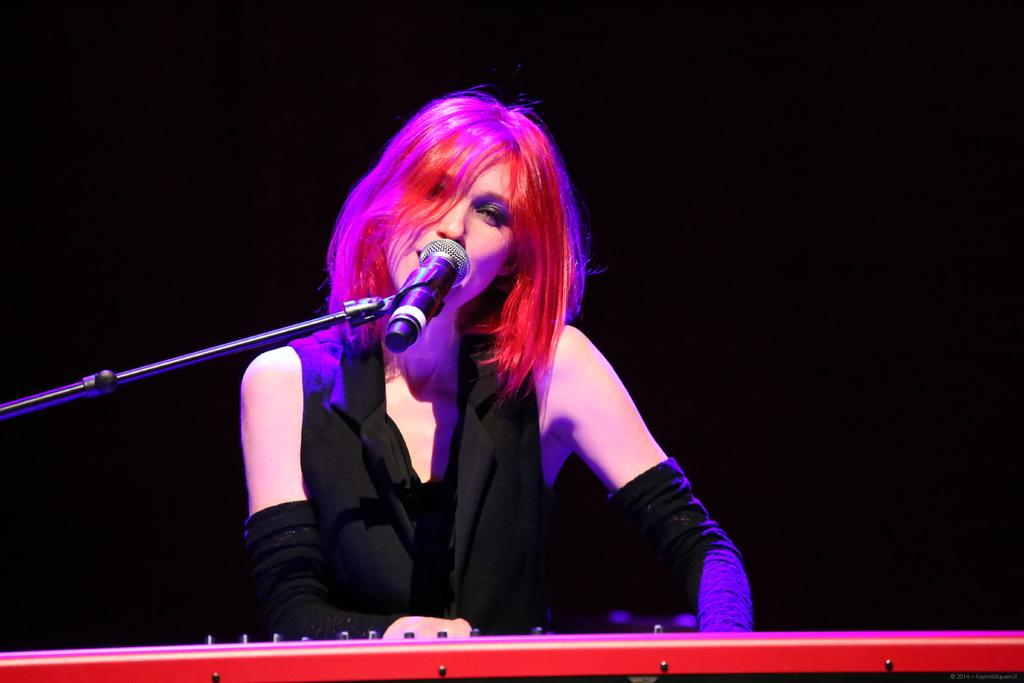What is the person in the image doing? The person is singing into a microphone. What object is in front of the person? There is a musical instrument in front of the person. Can you describe the background of the image? The background of the image appears to be dark. What type of jeans is the person wearing in the image? There is no information about the person's clothing in the image, so it cannot be determined if they are wearing jeans or any other type of clothing. What is the person using to play the string instrument in the image? There is no string instrument present in the image; the person is using a microphone for singing. 